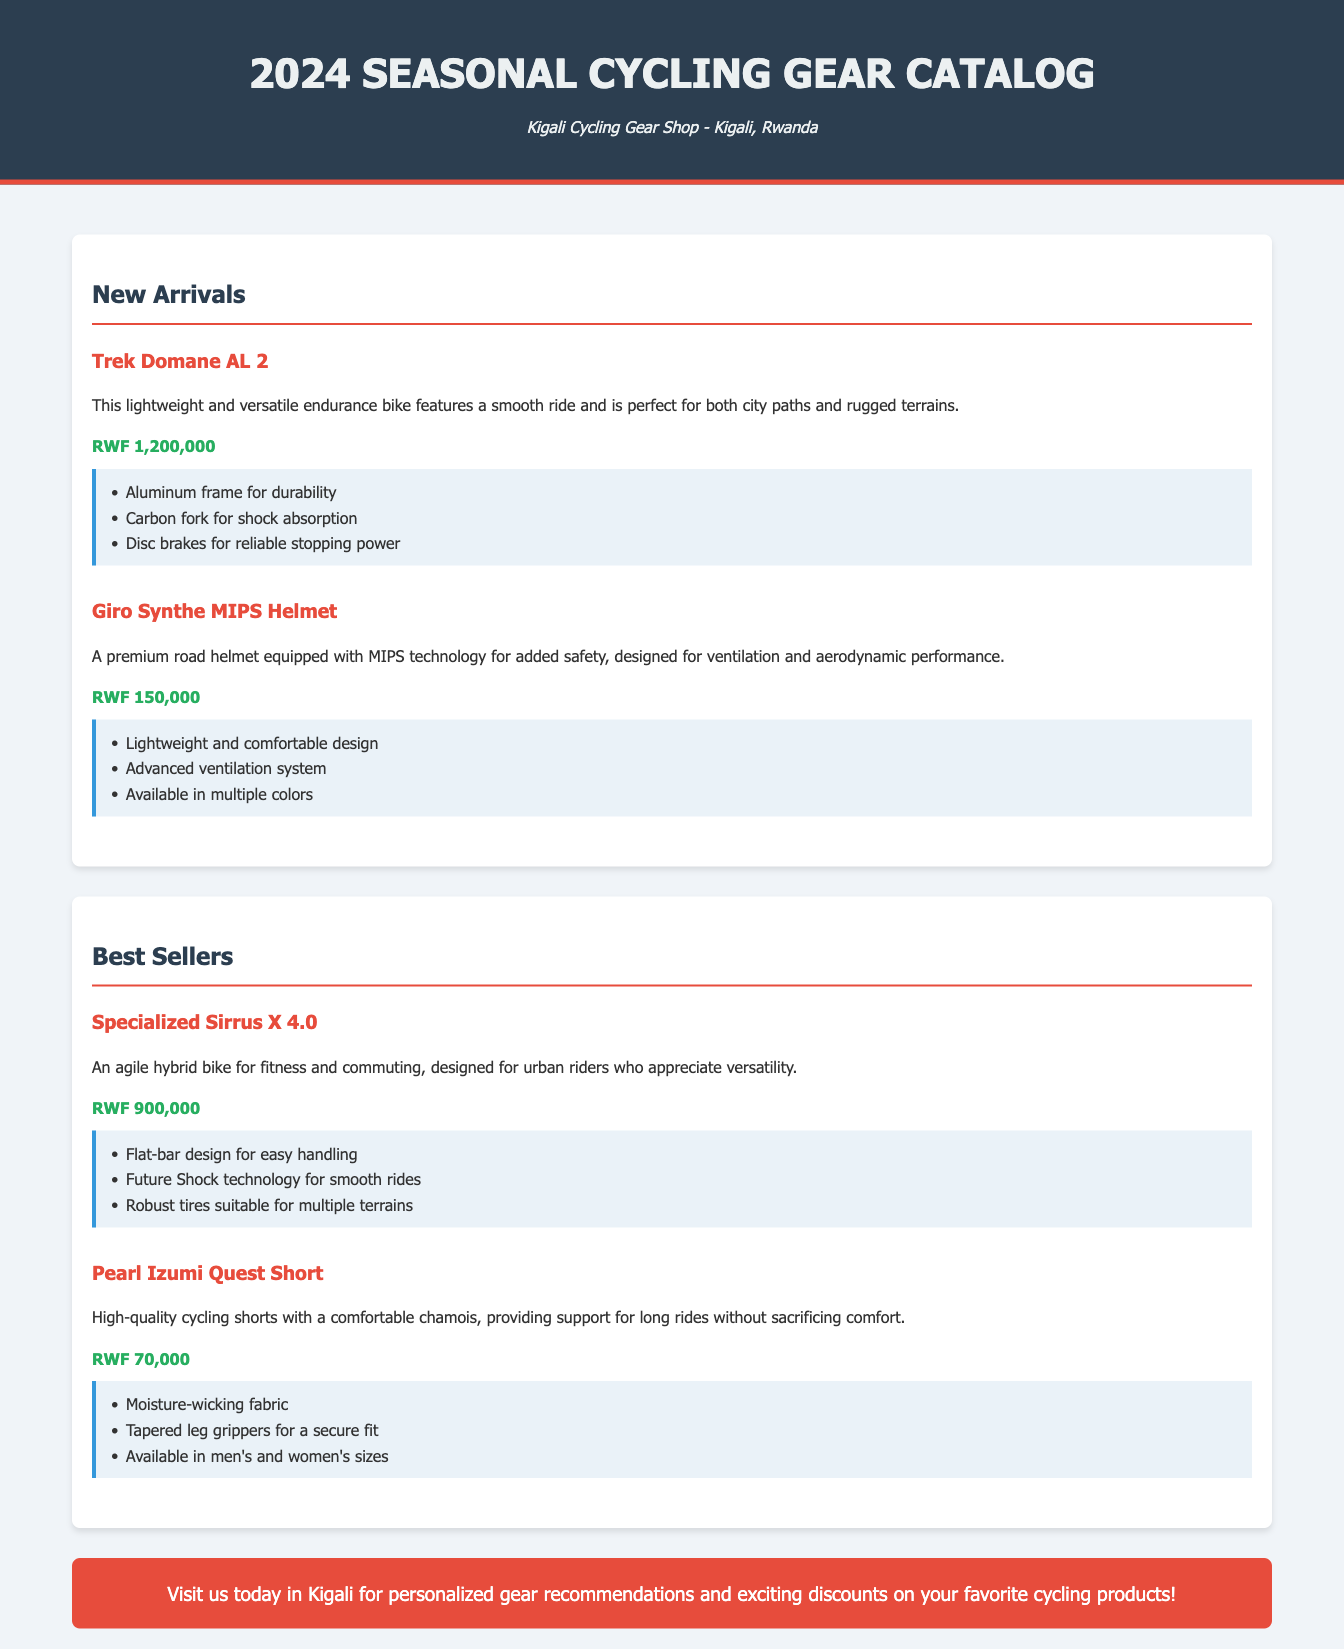what is the title of the catalog? The title of the catalog is displayed prominently at the top of the document.
Answer: 2024 Seasonal Cycling Gear Catalog who is the store owner? The document mentions the name of the store along with its location.
Answer: Kigali Cycling Gear Shop what is the price of the Giro Synthe MIPS Helmet? The price is listed directly beneath the item description for that product.
Answer: RWF 150,000 which bike is featured as a new arrival? The document lists new arrival products, and the bike's name is included in those items.
Answer: Trek Domane AL 2 how much does the Specialized Sirrus X 4.0 cost? The price for this best-selling item is specified under its description in the document.
Answer: RWF 900,000 what are the highlights of the Trek Domane AL 2? Each item in the catalog has a section for highlights, detailing key features.
Answer: Aluminum frame for durability, Carbon fork for shock absorption, Disc brakes for reliable stopping power which item has a moisture-wicking fabric? This feature is mentioned as part of the product description for specific items in the catalog.
Answer: Pearl Izumi Quest Short how many items are listed under new arrivals? The document presents the number of items featured under each section when counted.
Answer: 2 what type of helmet is the Giro Synthe? Each item's description includes the type or category it belongs to in the catalog.
Answer: Road helmet 